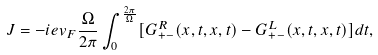<formula> <loc_0><loc_0><loc_500><loc_500>J = - i e v _ { F } \frac { \Omega } { 2 \pi } \int ^ { \frac { 2 \pi } { \Omega } } _ { 0 } [ G _ { + - } ^ { R } ( x , t , x , t ) - G _ { + - } ^ { L } ( x , t , x , t ) ] d t ,</formula> 